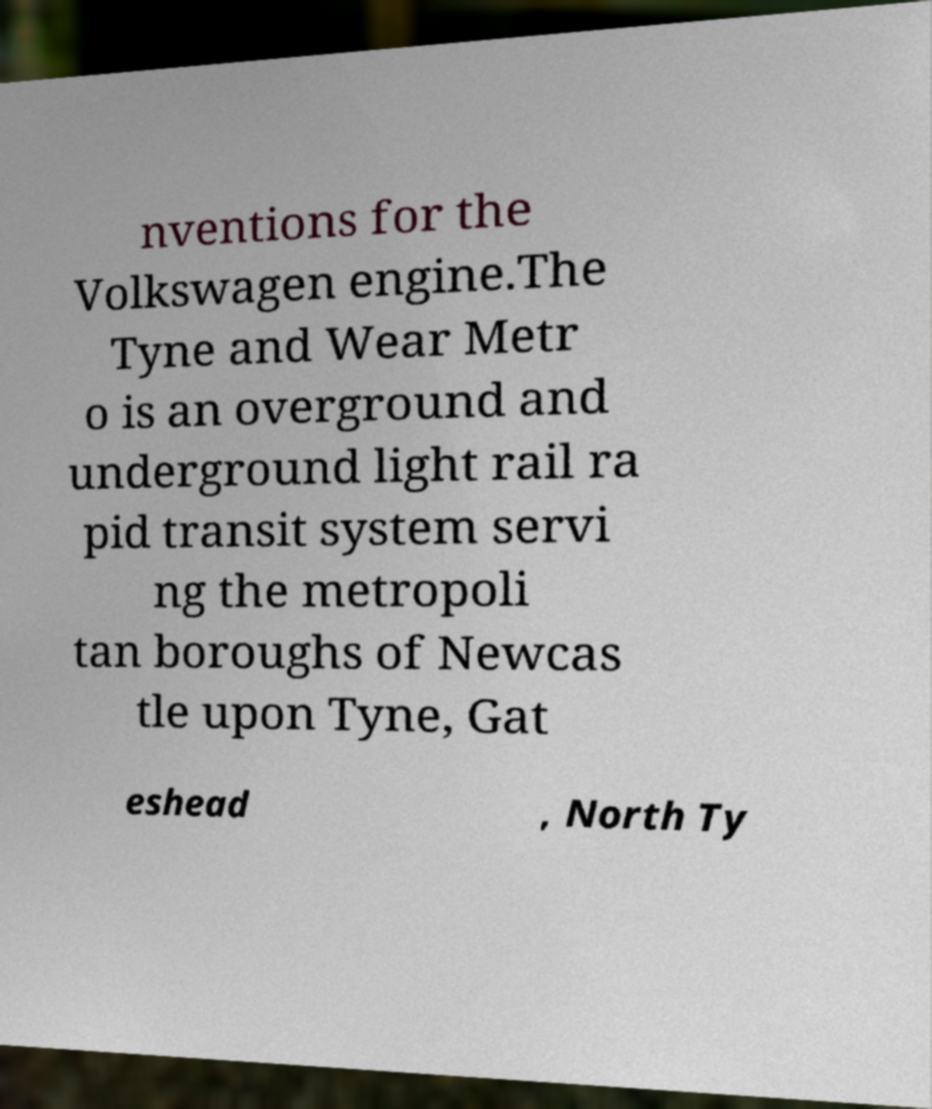There's text embedded in this image that I need extracted. Can you transcribe it verbatim? nventions for the Volkswagen engine.The Tyne and Wear Metr o is an overground and underground light rail ra pid transit system servi ng the metropoli tan boroughs of Newcas tle upon Tyne, Gat eshead , North Ty 